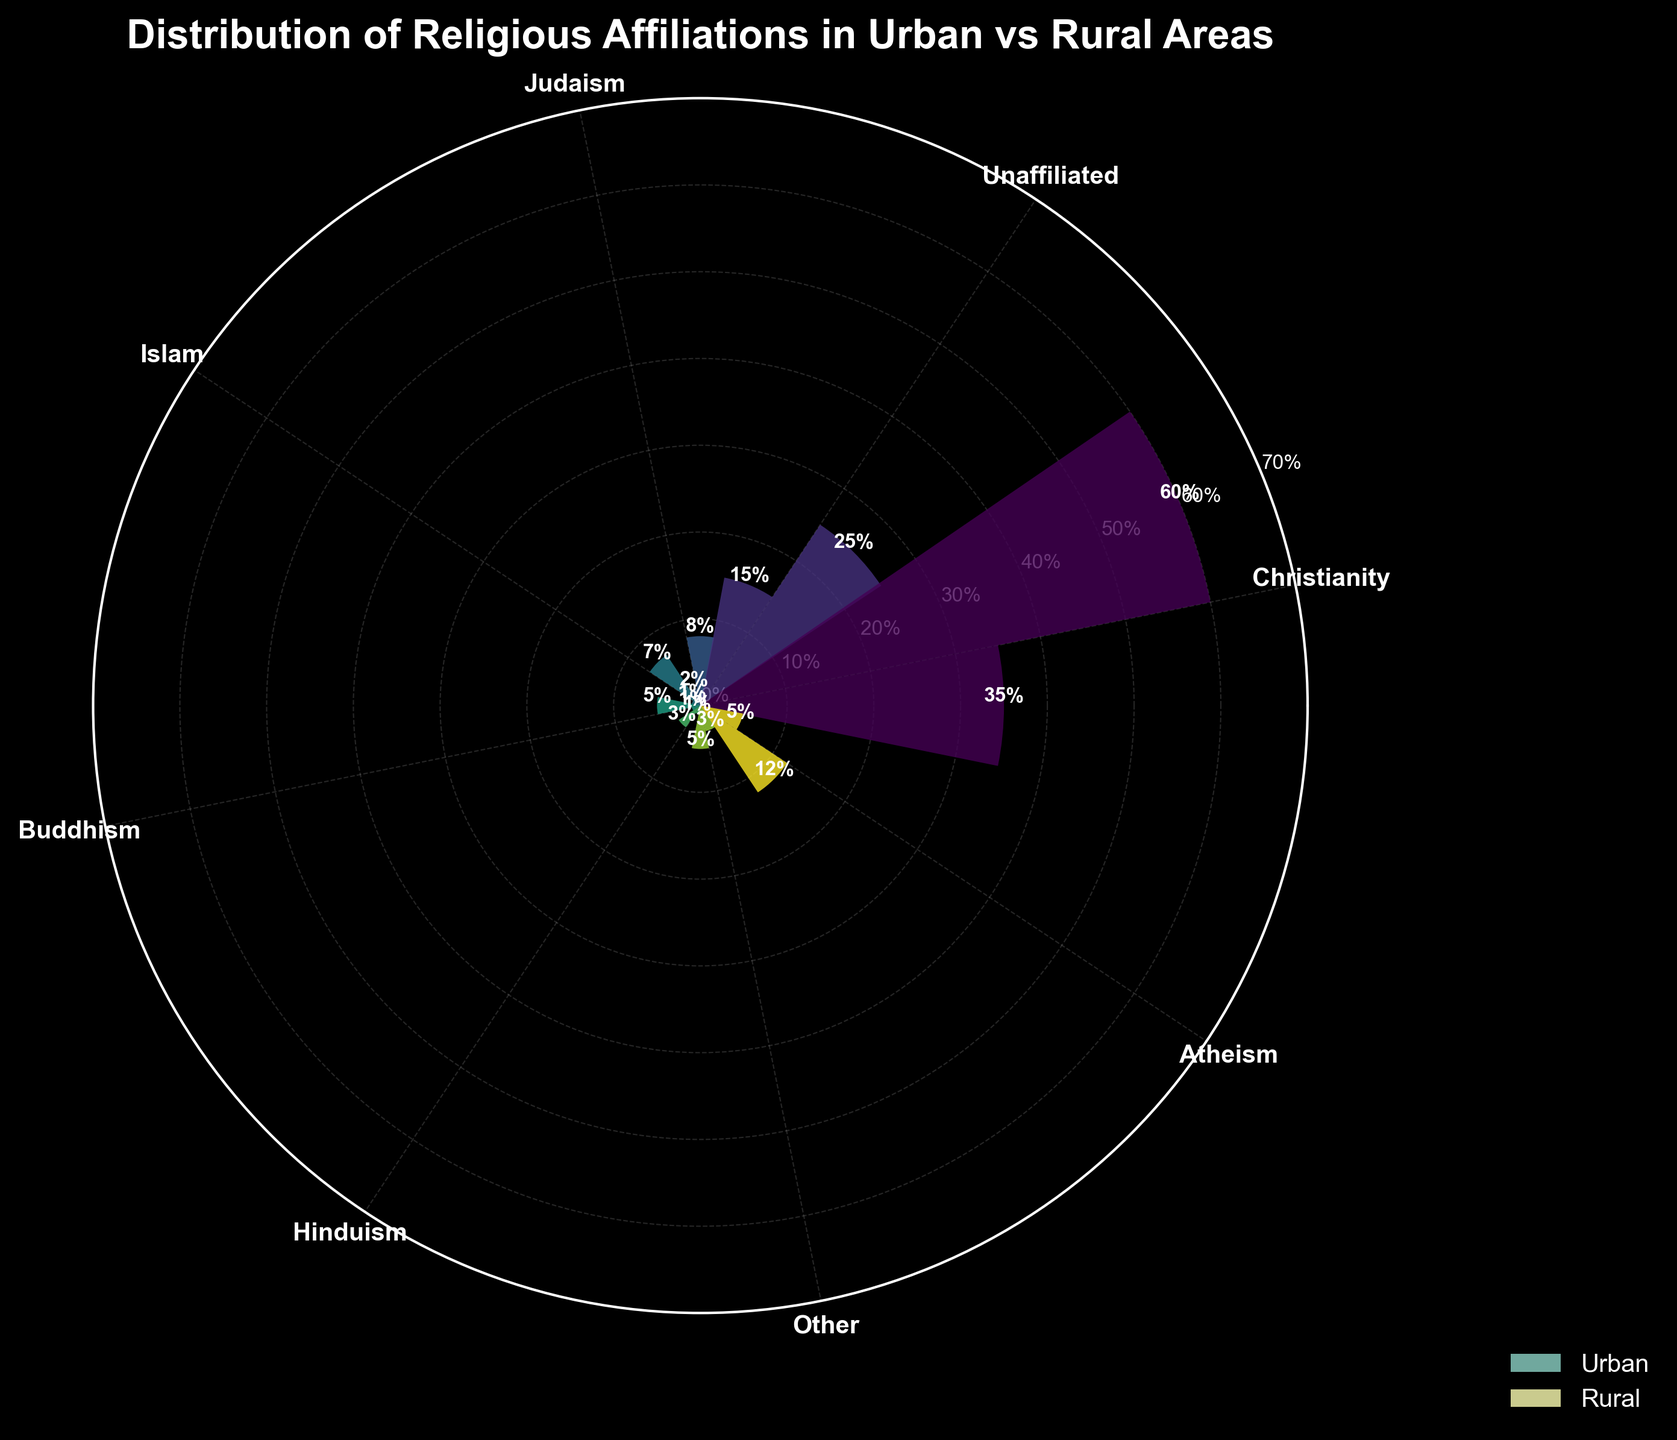What is the title of the figure? The title is shown at the top of the figure. It is written in large, bold text to capture attention and summarize the content
Answer: Distribution of Religious Affiliations in Urban vs Rural Areas Which religious affiliation has the highest percentage in urban areas? The urban bars are represented in a radial style. By checking each segment, Christianity has the largest percentage.
Answer: Christianity How much higher is the percentage of Christianity in rural areas compared to urban areas? Find the height of the Christian bars in both urban and rural segments. Subtract the urban percentage from the rural percentage: 60% - 35% = 25%
Answer: 25% What is the percentage of people who identify as unaffiliated in urban areas? Look for the bar labeled "Unaffiliated" within the urban section of the polar chart. The height indicates the percentage.
Answer: 25% What religious affiliation has the lowest representation in rural areas? Identify the shortest bar within the rural section of the chart. Islam, Buddhism, and Hinduism all have similar low bars, but ultimately share the lowest values.
Answer: Islam, Buddhism, and Hinduism What is the total percentage combination of Judaism, Islam, and Buddhism in urban areas? Sum the urban percentages for Judaism (8%), Islam (7%), and Buddhism (5%): 8% + 7% + 5% = 20%
Answer: 20% How does the percentage of atheism differ between urban and rural areas? Compare the heights of the atheism bars in both the urban and rural sections. Subtract the rural percentage from the urban percentage: 12% - 5% = 7%
Answer: 7% Which religious affiliation has the most significant difference between urban and rural areas? Examine the bars for each affiliation in both urban and rural areas, looking for the largest difference in height. Christianity has the most significant difference: 25%.
Answer: Christianity What is the combined percentage of "Other" affiliations in both urban and rural areas? Add the percentages of the "Other" category in urban (5%) and rural (3%) areas: 5% + 3% = 8%
Answer: 8% How many affiliations have a higher percentage in urban areas compared to rural areas? Review each bar category, noting whether the urban bar is taller. Unaffiliated, Judaism, Islam, Buddhism, Hinduism, Other, and Atheism have higher values in urban areas. Count these categories: 7
Answer: 7 